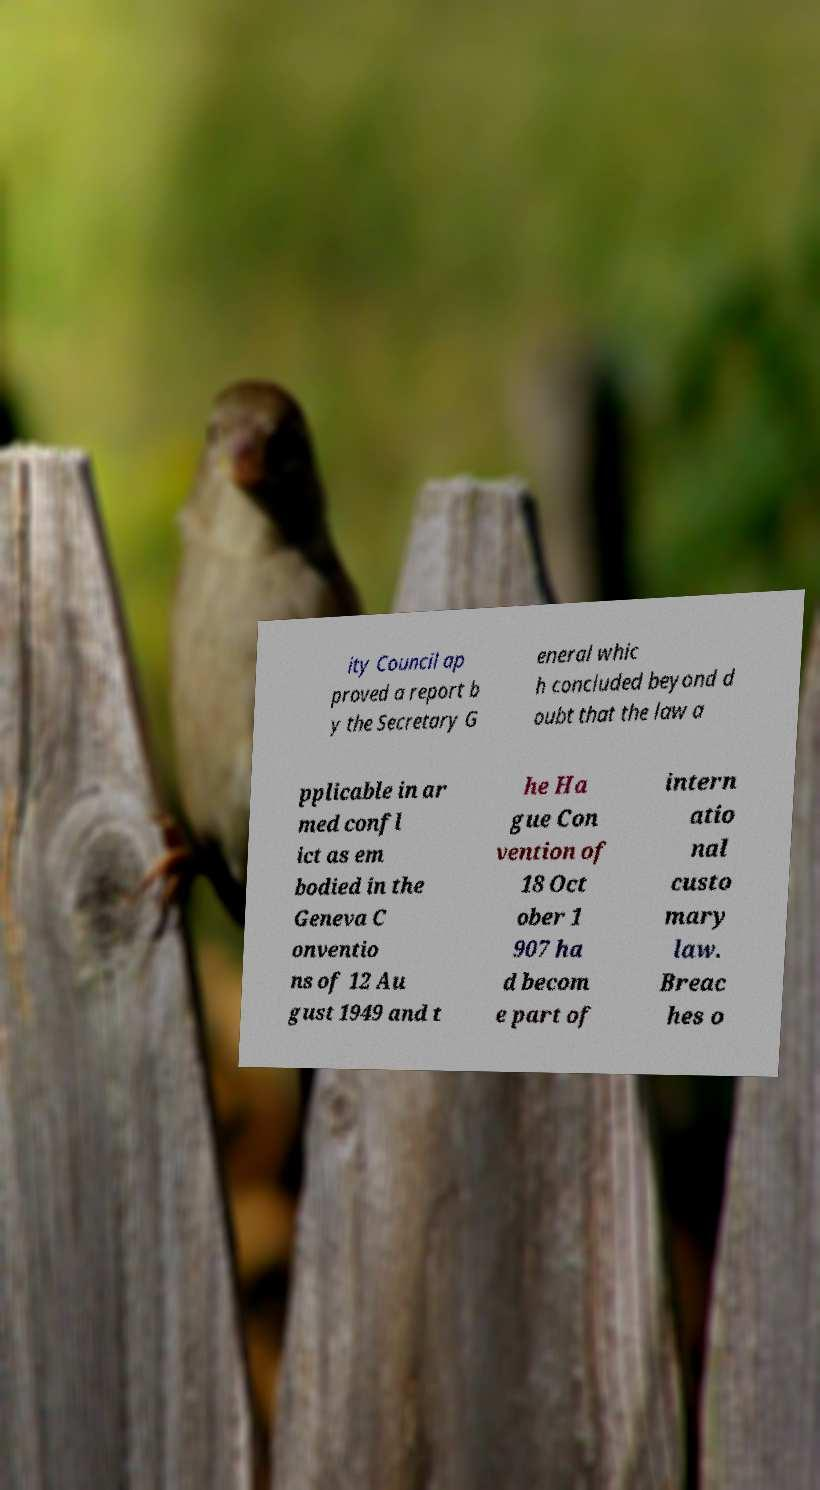There's text embedded in this image that I need extracted. Can you transcribe it verbatim? ity Council ap proved a report b y the Secretary G eneral whic h concluded beyond d oubt that the law a pplicable in ar med confl ict as em bodied in the Geneva C onventio ns of 12 Au gust 1949 and t he Ha gue Con vention of 18 Oct ober 1 907 ha d becom e part of intern atio nal custo mary law. Breac hes o 